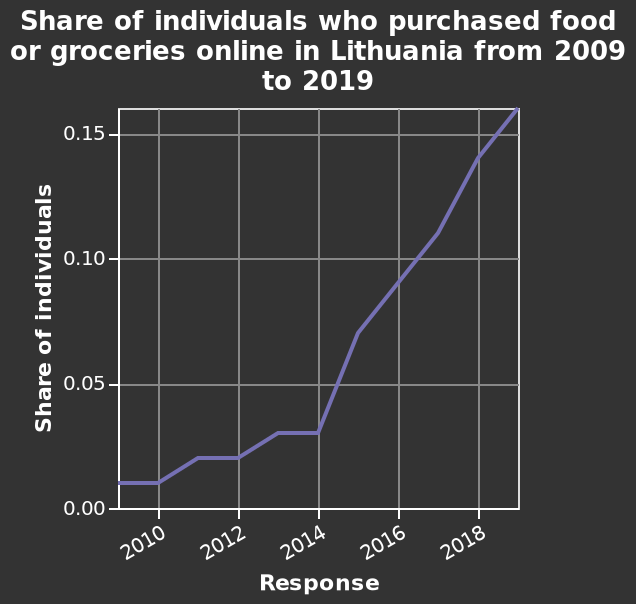<image>
How would you describe the change in the share after 2014? The share increased drastically after 2014. Describe the following image in detail Share of individuals who purchased food or groceries online in Lithuania from 2009 to 2019 is a line graph. There is a scale from 0.00 to 0.15 along the y-axis, labeled Share of individuals. A linear scale of range 2010 to 2018 can be found along the x-axis, marked Response. What is the title or label given to the x-axis? The x-axis is labeled as "Response" representing the different years from 2010 to 2018. 